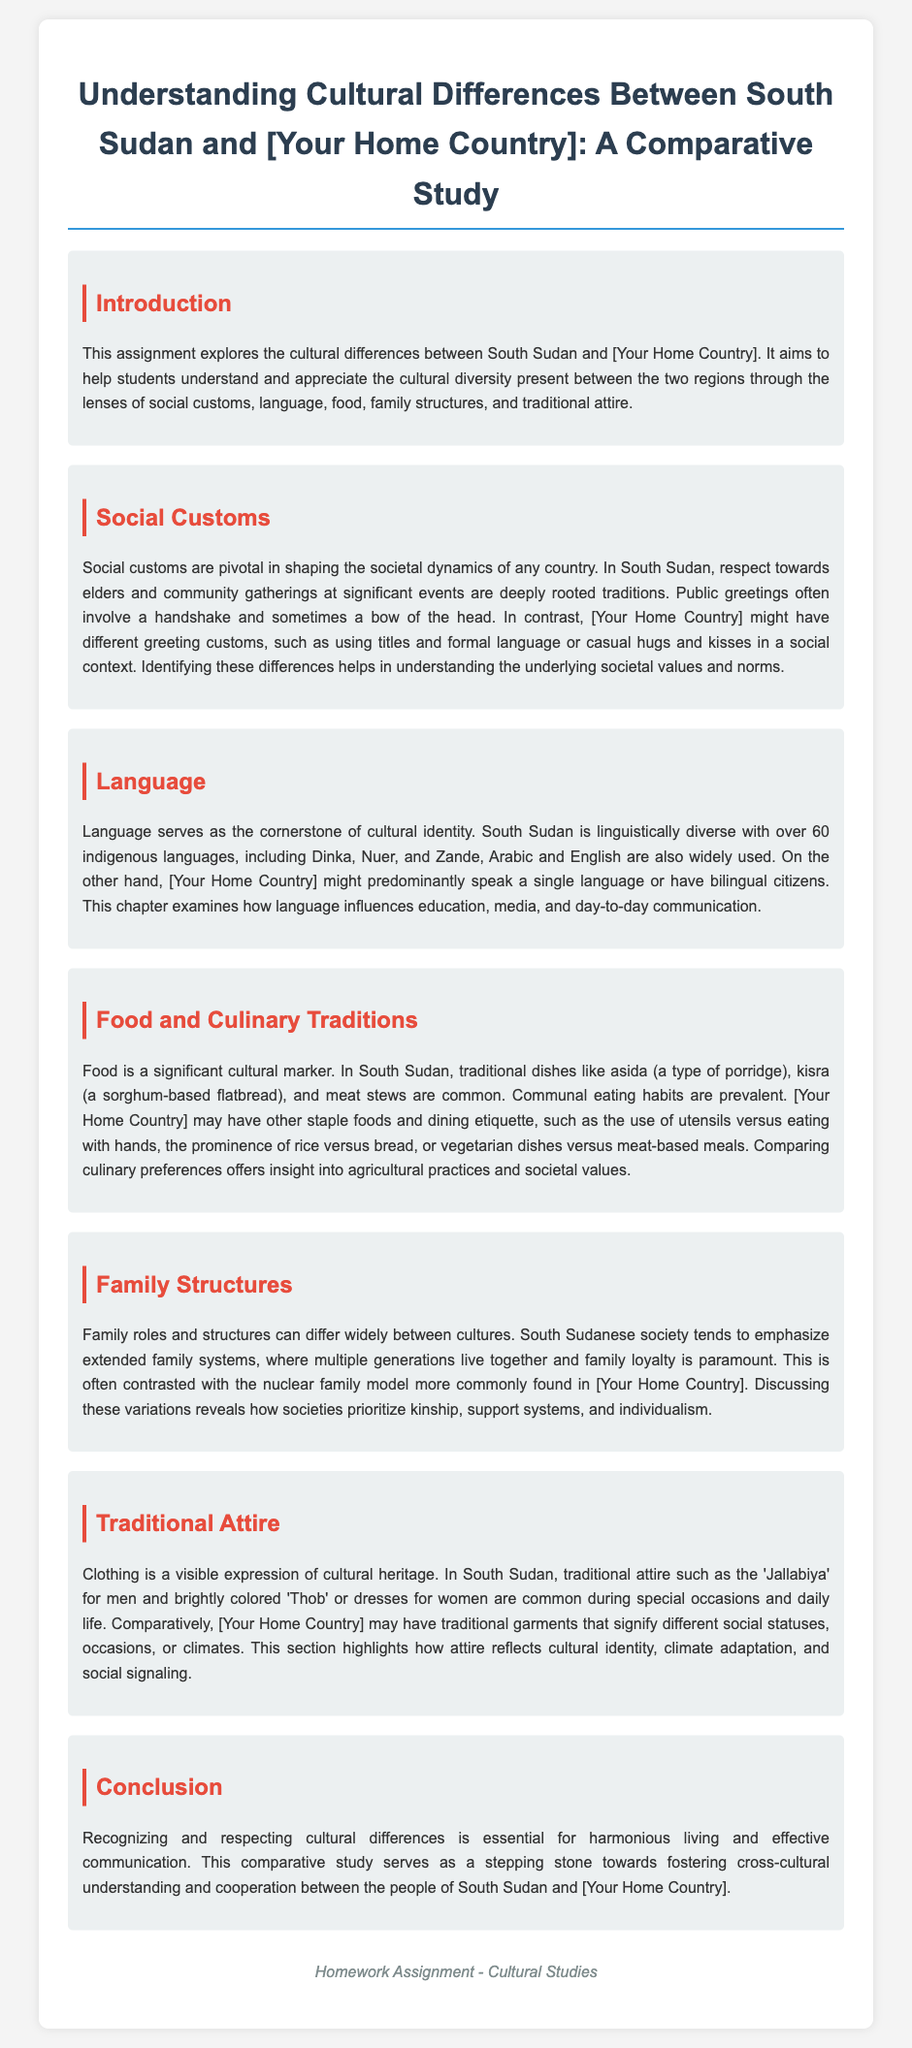what is the title of the assignment? The title of the assignment is explicitly stated at the beginning of the document.
Answer: Understanding Cultural Differences Between South Sudan and [Your Home Country]: A Comparative Study how many indigenous languages are spoken in South Sudan? The document mentions that South Sudan is linguistically diverse with over 60 indigenous languages.
Answer: over 60 what traditional dish is commonly eaten in South Sudan? The document lists several traditional dishes, one of which is asida, a type of porridge.
Answer: asida what family structure is emphasized in South Sudanese society? The document states that South Sudanese society tends to emphasize extended family systems.
Answer: extended family systems which traditional attire is mentioned for men in South Sudan? The document refers to Jallabiya as traditional attire worn by men in South Sudan.
Answer: Jallabiya how does the document suggest cultural differences impact communication? The conclusion states that recognizing and respecting cultural differences is essential for effective communication.
Answer: effective communication what social custom is noted during public greetings in South Sudan? The document mentions that public greetings often involve a handshake.
Answer: handshake which aspect of culture does the document compare through food? The document suggests comparing culinary preferences to gain insight into agricultural practices and societal values.
Answer: agricultural practices and societal values 